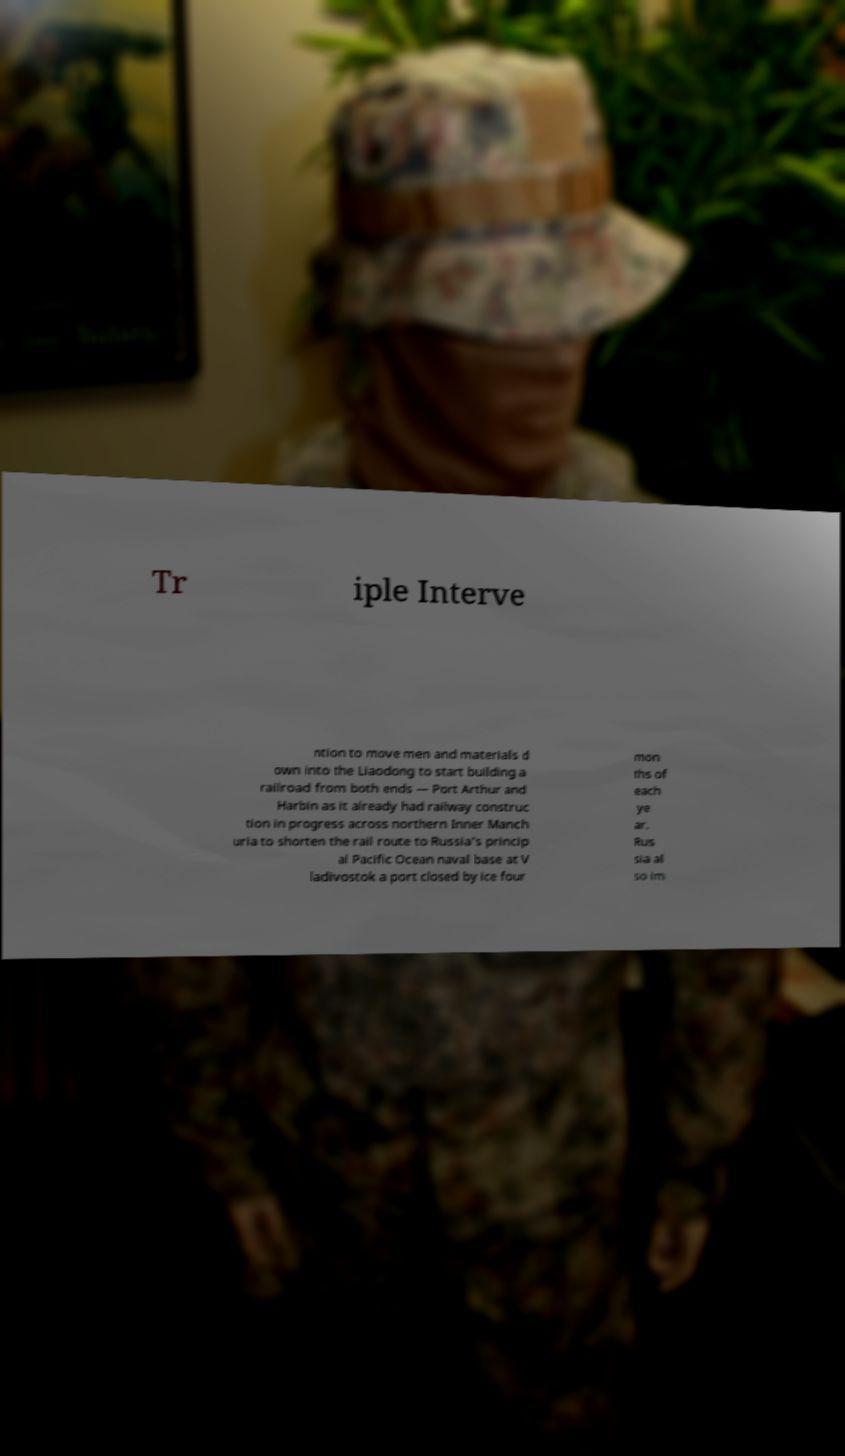What messages or text are displayed in this image? I need them in a readable, typed format. Tr iple Interve ntion to move men and materials d own into the Liaodong to start building a railroad from both ends — Port Arthur and Harbin as it already had railway construc tion in progress across northern Inner Manch uria to shorten the rail route to Russia's princip al Pacific Ocean naval base at V ladivostok a port closed by ice four mon ths of each ye ar. Rus sia al so im 